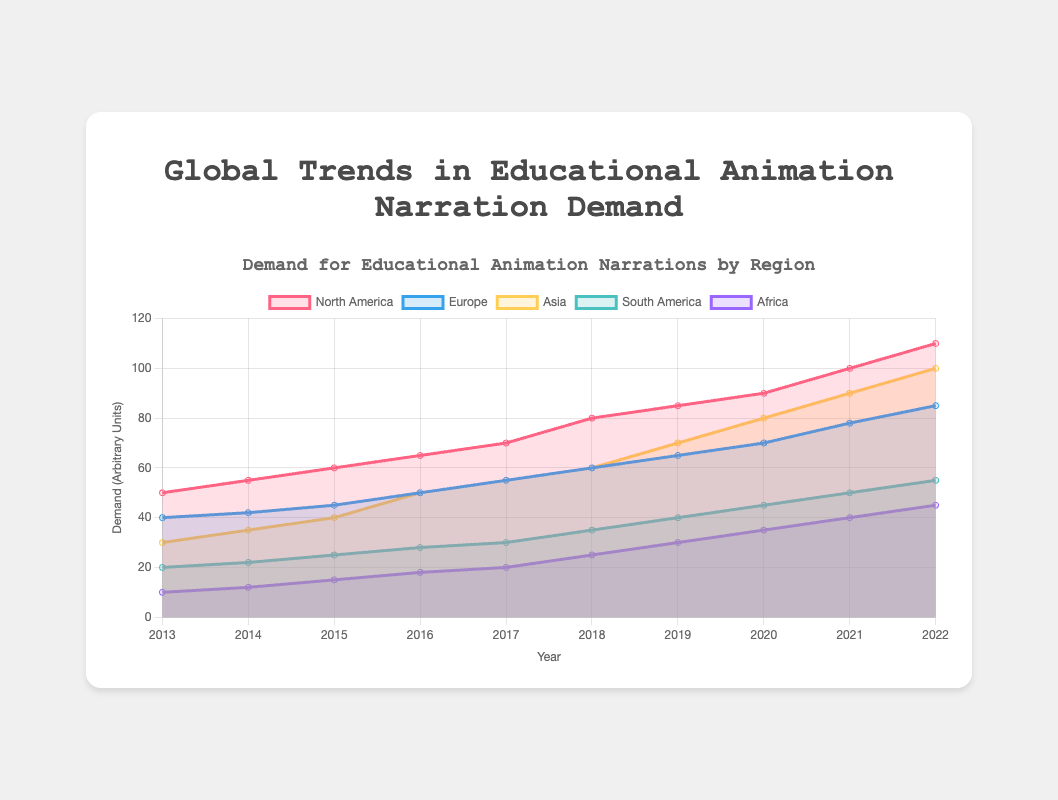Which region had the highest demand for educational animation narrations in 2022? We can see from the area chart that the regions are represented by different colors and North America, with the highest data point at 110, leads the other regions in demand for 2022.
Answer: North America What is the general trend in the demand for educational animation narrations in Asia from 2013 to 2022? By observing the area representing Asia, we see a consistent increase from 30 in 2013 to 100 in 2022, showing a strong upward trend.
Answer: Upward trend Which two regions had similar levels of demand around 2015? The areas for Asia and South America display a similar pattern in 2015, with Asia at 40 and South America at 25, making them close in values.
Answer: Asia and South America How does the demand trend for Europe compare to that of Africa over the decade? Throughout the area chart from 2013 to 2022, Europe's demand shows a more significant increase, starting at 40 and ending at 85, while Africa starts low at 10 and ends at 45. This comparison indicates Europe has a steeper upward trend compared to Africa.
Answer: Europe's growth is steeper In which year did North America see the most substantial increase in demand compared to the previous year? Examining the specific increases year over year for North America in the chart, the largest jump happens from 2017 (70) to 2018 (80), with an increase of 10 units.
Answer: 2018 By how much did the demand for educational animation narrations in South America increase from 2013 to 2022? To find the increase, subtract the 2013 value from the 2022 value for South America: 55-20 = 35 units.
Answer: 35 units What is the average demand for educational animation narrations in Africa from 2013 to 2022? Adding up the values for Africa from each year and dividing by the number of years yields: (10 + 12 + 15 + 18 + 20 + 25 + 30 + 35 + 40 + 45) / 10 = 25 units (arbitrary units).
Answer: 25 units Which region experienced the most consistent growth rate in demand over the past decade? By examining the slopes of the areas in the chart, the smooth upward slope for Europe suggests it had the most consistent growth as opposed to areas with more fluctuation.
Answer: Europe In what year did Asia's demand meet and surpass that of Europe? Observing the chart, the point where the area representing Asia overtakes Europe is in 2020, highlighted by the intersection and subsequent higher trajectory of Asia's area compared to Europe.
Answer: 2020 